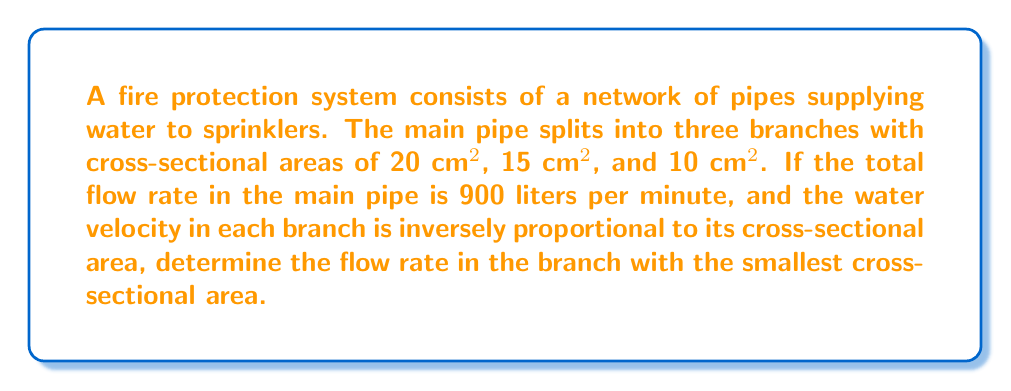Teach me how to tackle this problem. Let's approach this step-by-step using principles of fluid dynamics and linear algebra:

1) First, let's define variables:
   $Q_t$ = total flow rate = 900 L/min
   $A_1 = 20$ cm², $A_2 = 15$ cm², $A_3 = 10$ cm²
   $Q_1, Q_2, Q_3$ = flow rates in each branch

2) We know that the total flow rate is the sum of the branch flow rates:
   $$Q_t = Q_1 + Q_2 + Q_3$$

3) Flow rate is the product of velocity and cross-sectional area:
   $$Q = v \cdot A$$

4) We're told that velocity is inversely proportional to area. Let's call the constant of proportionality $k$:
   $$v = \frac{k}{A}$$

5) Substituting this into the flow rate equation:
   $$Q = \frac{k}{A} \cdot A = k$$

6) This means the flow rate in each branch is constant! Let's call this constant $c$:
   $$Q_1 = Q_2 = Q_3 = c$$

7) Substituting into the total flow rate equation:
   $$Q_t = c + c + c = 3c$$

8) Solving for $c$:
   $$c = \frac{Q_t}{3} = \frac{900}{3} = 300$$

9) Therefore, the flow rate in each branch, including the one with the smallest cross-sectional area, is 300 L/min.
Answer: 300 L/min 